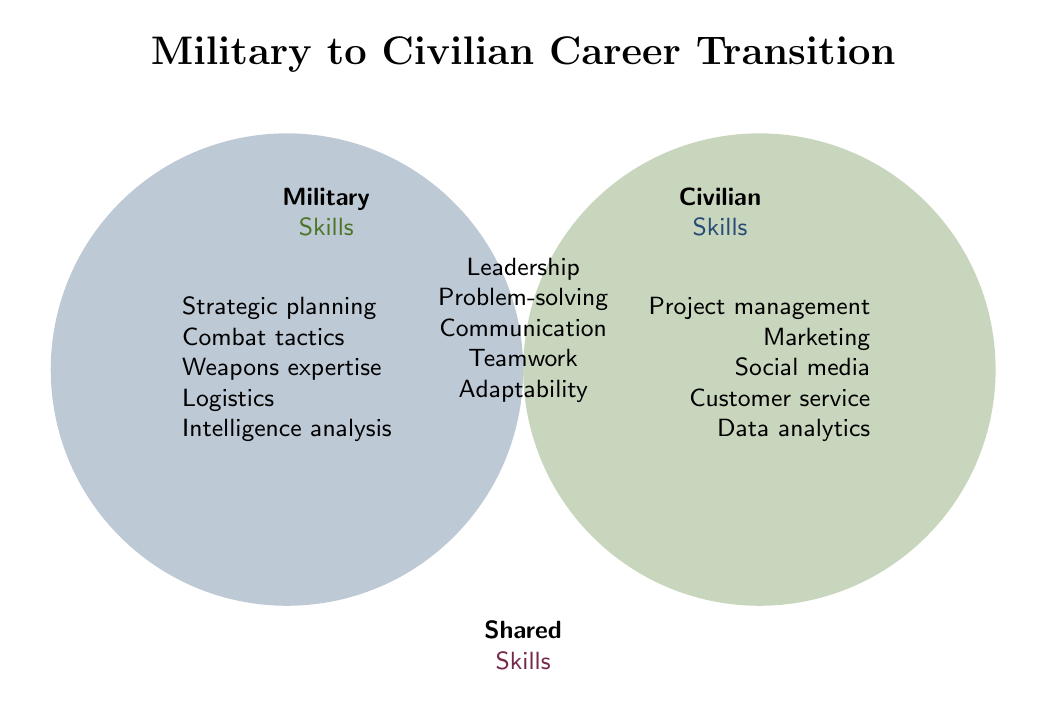What are the three different skill categories shown in the Venn Diagram? The Venn Diagram shows three skill categories labeled as "Military Skills," "Civilian Skills," and "Shared Skills."
Answer: Military Skills, Civilian Skills, Shared Skills Which category includes 'Leadership'? 'Leadership' is located in the overlap area of the Venn Diagram, indicating it is a shared skill between Military and Civilian categories.
Answer: Shared Skills List two skills that are exclusive to the Civilian category. The Civilian category includes skills listed on the left side. Two examples are 'Marketing strategy' and 'Data analytics.'
Answer: Marketing strategy, Data analytics How many skills are shared between Military and Civilian categories? The shared area between Military and Civilian circles contains 9 skills. These are Leadership, Problem-solving, Communication, Teamwork, Adaptability, Time management, Critical thinking, Decision-making, and Stress management.
Answer: 9 Which skill appears in both Military and Civilian categories but not in Shared Skills? The Venn Diagram does not depict any skill that is present in both Military and Civilian categories without being in the Shared Skills section.
Answer: None Compare the number of skills exclusive to Military and Civilian categories. Which has more? By counting, the Military category includes 9 exclusive skills while the Civilian category includes 9 exclusive skills. Both categories have an equal number of exclusive skills.
Answer: Equal Identify one military-related skill that might be useful in a logistics job in the civilian sector. 'Logistics management' is a skill in the Military category that would be particularly useful in a civilian logistics job.
Answer: Logistics management Which category includes 'Time management'? 'Time management' is included in the Shared Skills category, located in the overlapping area of the Venn Diagram.
Answer: Shared Skills Find a skill in the Civilian category that might be surprising to a transitioning military professional. 'Social media management' might be surprising to a transitioning military professional as it's generally not associated with typical military tasks.
Answer: Social media management How many skills are listed in the Military Skills category? The Military Skills category lists 9 exclusive skills: Strategic planning, Combat tactics, Weapons expertise, Logistics management, Intelligence analysis, Physical training, Military regulations, Convoy operations, and Field medicine.
Answer: 9 